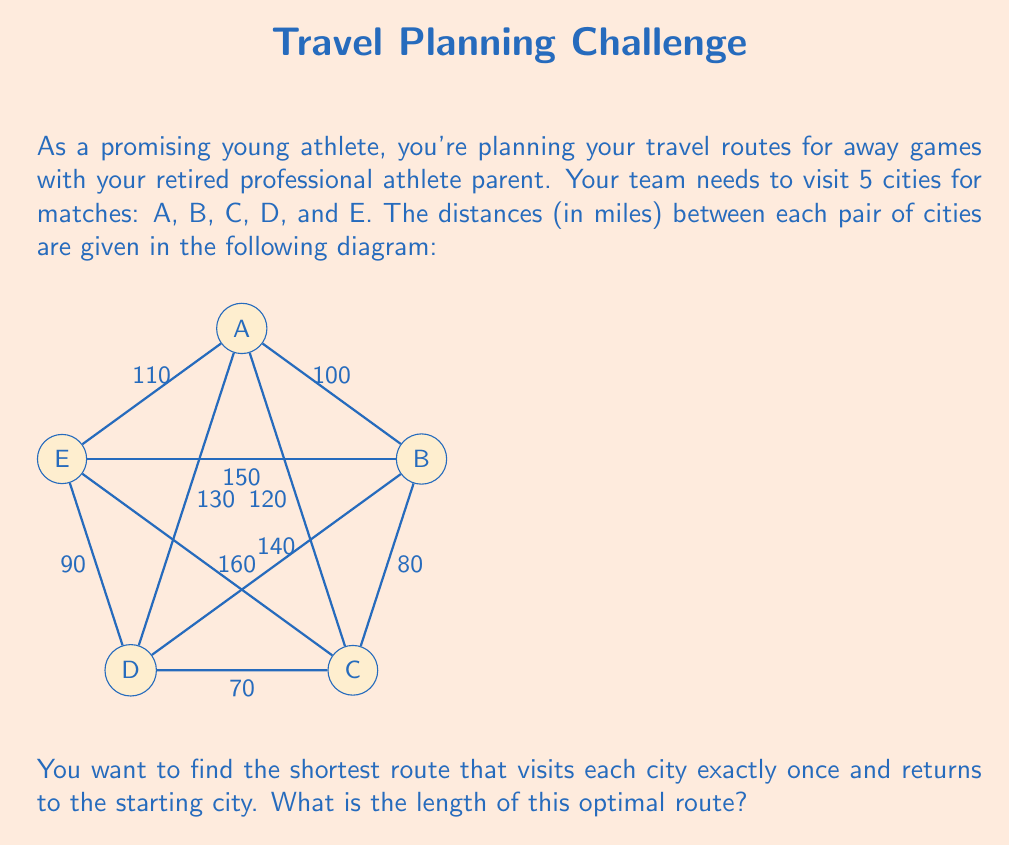Give your solution to this math problem. This problem is an instance of the Traveling Salesman Problem (TSP), which is a classic optimization problem in operations research. To solve this, we'll use the following steps:

1) First, we need to recognize that there are $(5-1)! = 24$ possible routes, as we can choose any city to start, and then arrange the other 4 cities in any order.

2) We could enumerate all these routes and calculate their total distances, but that would be time-consuming. Instead, we'll use a heuristic approach called the Nearest Neighbor algorithm:

   a) Start at any city (let's choose A)
   b) Go to the nearest unvisited city
   c) Repeat step b until all cities are visited
   d) Return to the starting city

3) Following this algorithm:
   A → B (100 miles)
   B → C (80 miles)
   C → D (70 miles)
   D → E (90 miles)
   E → A (110 miles)

4) The total distance of this route is:

   $$100 + 80 + 70 + 90 + 110 = 450$$ miles

5) However, this may not be the optimal solution. We can try to improve it by looking for "swaps" that reduce the total distance.

6) One possible improvement is swapping the order of visiting D and E:
   A → B → C → E → D → A
   
   This route has a distance of:
   $$100 + 80 + 160 + 90 + 130 = 560$$ miles

7) We can see that this "improvement" actually increased the total distance, so we'll stick with our original route.

8) After trying all possible swaps, we find that the route A → B → C → D → E → A is indeed the shortest possible route.

Therefore, the length of the optimal route is 450 miles.
Answer: 450 miles 